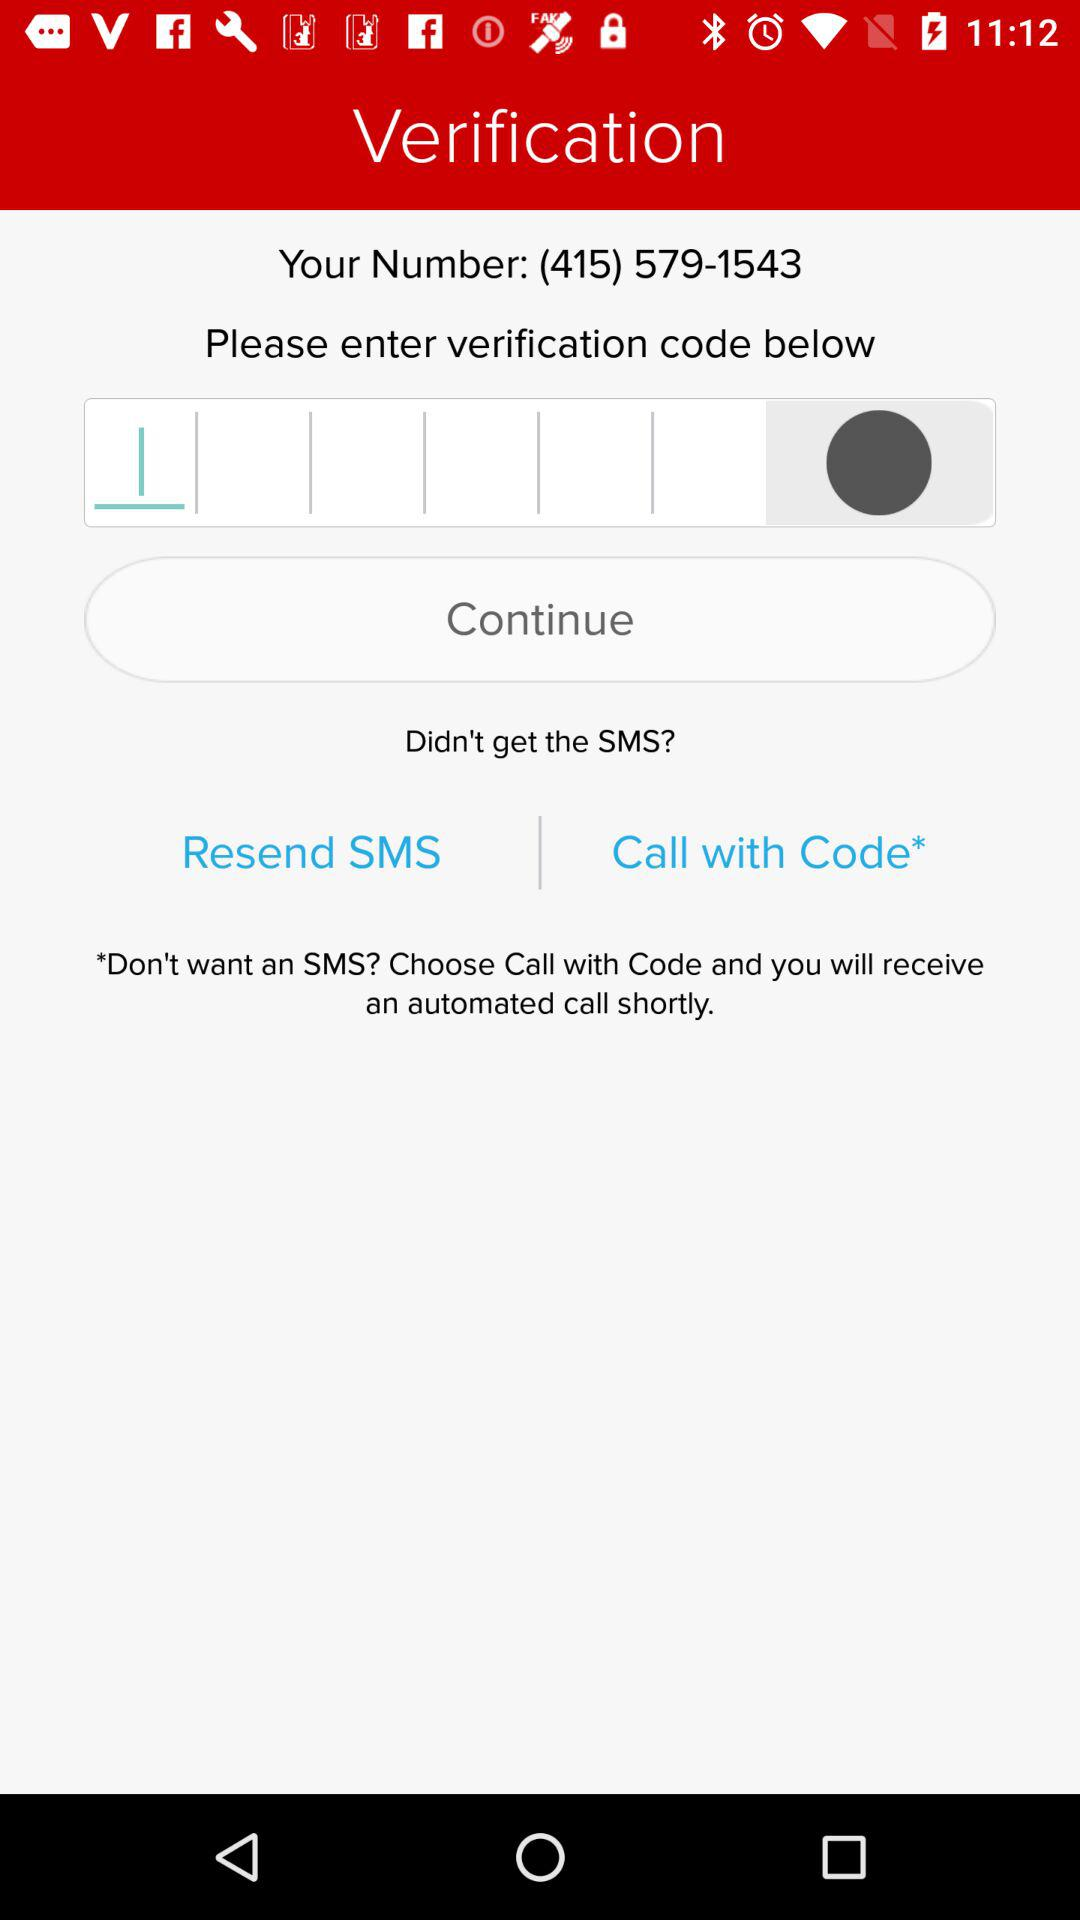How many options are there to resend the verification code?
Answer the question using a single word or phrase. 2 